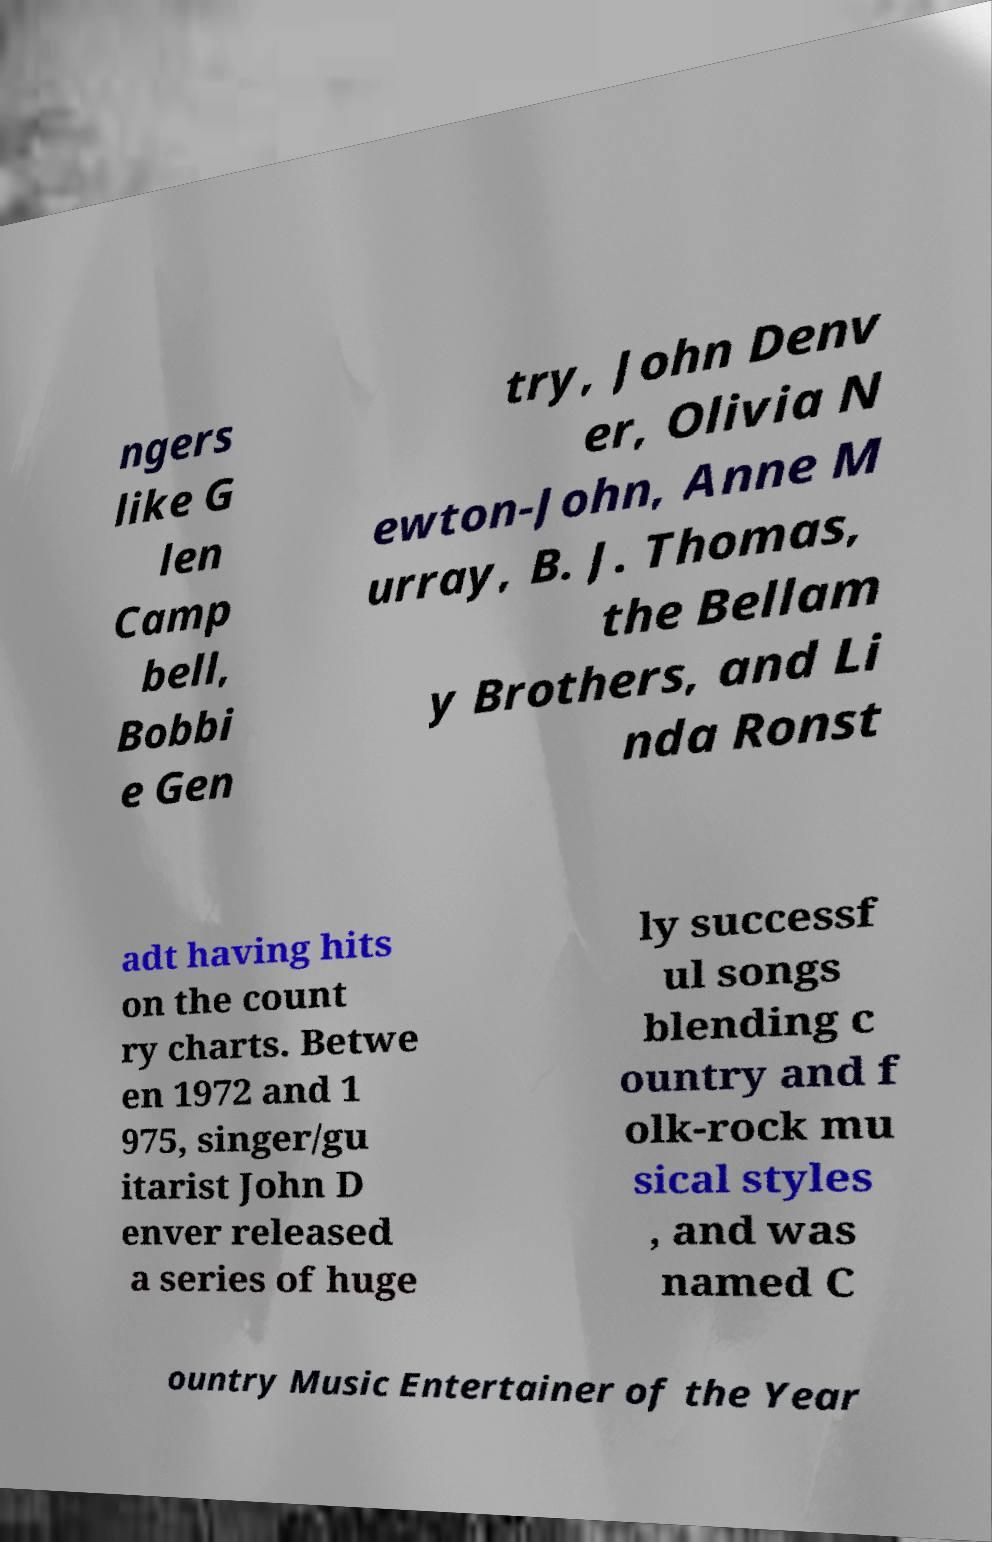What messages or text are displayed in this image? I need them in a readable, typed format. ngers like G len Camp bell, Bobbi e Gen try, John Denv er, Olivia N ewton-John, Anne M urray, B. J. Thomas, the Bellam y Brothers, and Li nda Ronst adt having hits on the count ry charts. Betwe en 1972 and 1 975, singer/gu itarist John D enver released a series of huge ly successf ul songs blending c ountry and f olk-rock mu sical styles , and was named C ountry Music Entertainer of the Year 